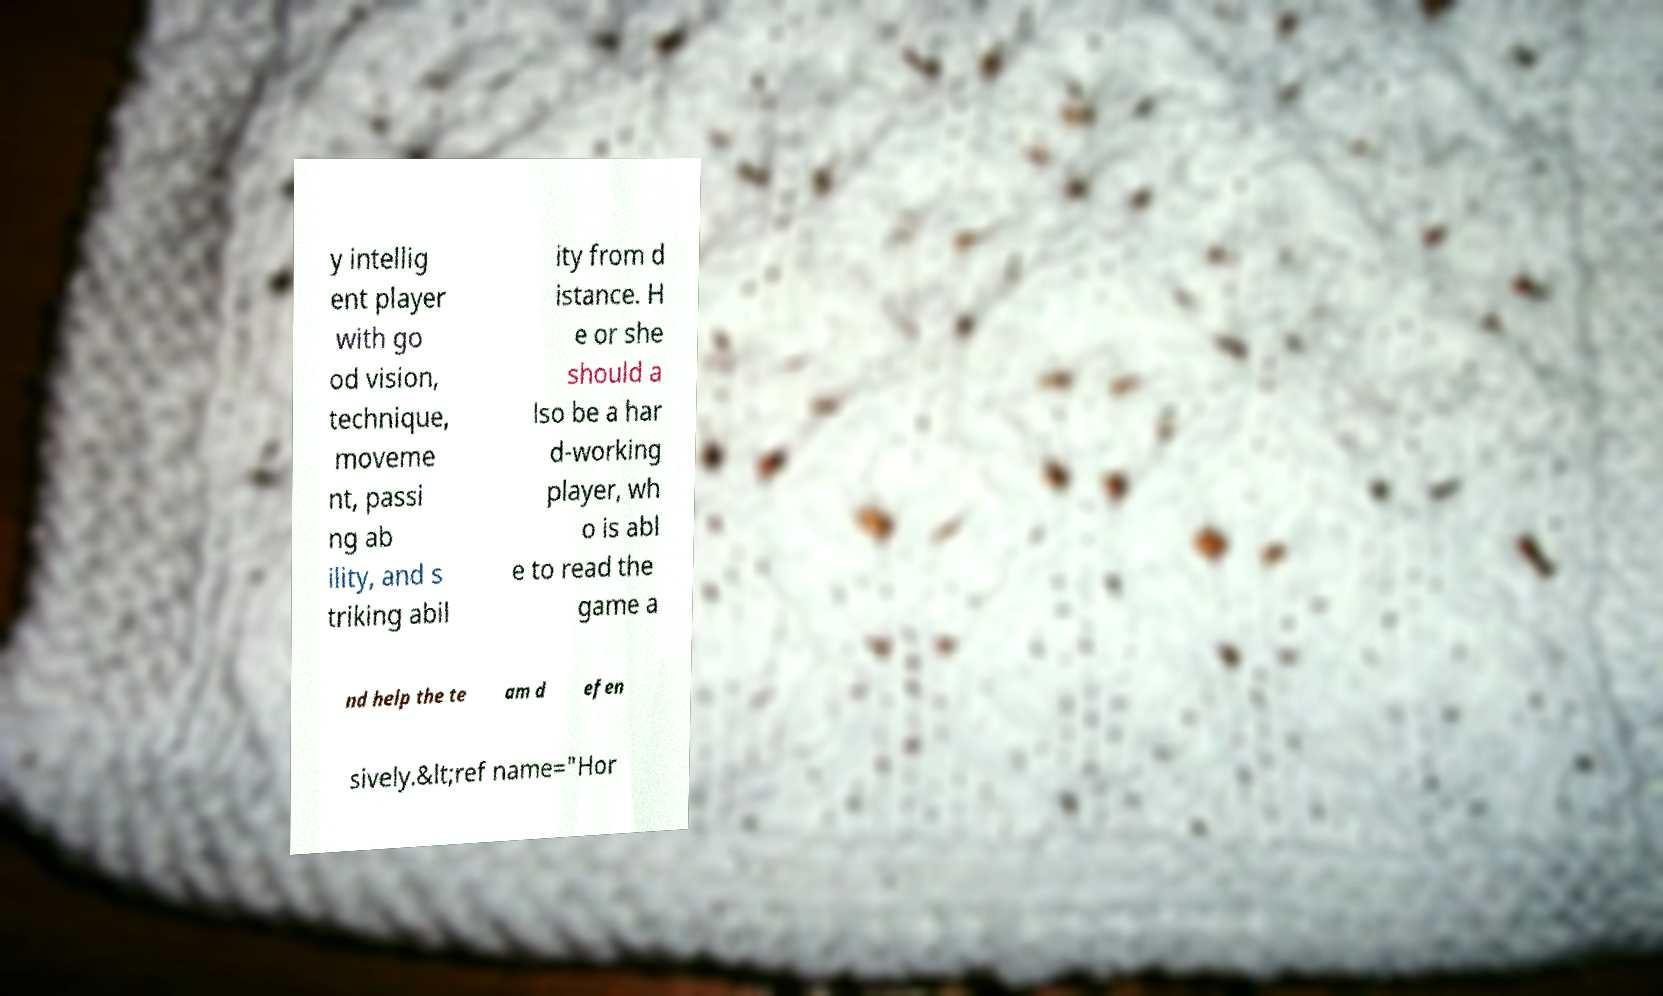Please read and relay the text visible in this image. What does it say? y intellig ent player with go od vision, technique, moveme nt, passi ng ab ility, and s triking abil ity from d istance. H e or she should a lso be a har d-working player, wh o is abl e to read the game a nd help the te am d efen sively.&lt;ref name="Hor 